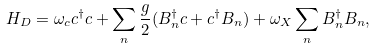Convert formula to latex. <formula><loc_0><loc_0><loc_500><loc_500>H _ { D } = \omega _ { c } c ^ { \dagger } c + \sum _ { n } \frac { g } { 2 } ( B ^ { \dagger } _ { n } c + c ^ { \dagger } B _ { n } ) + \omega _ { X } \sum _ { n } B ^ { \dagger } _ { n } B _ { n } ,</formula> 